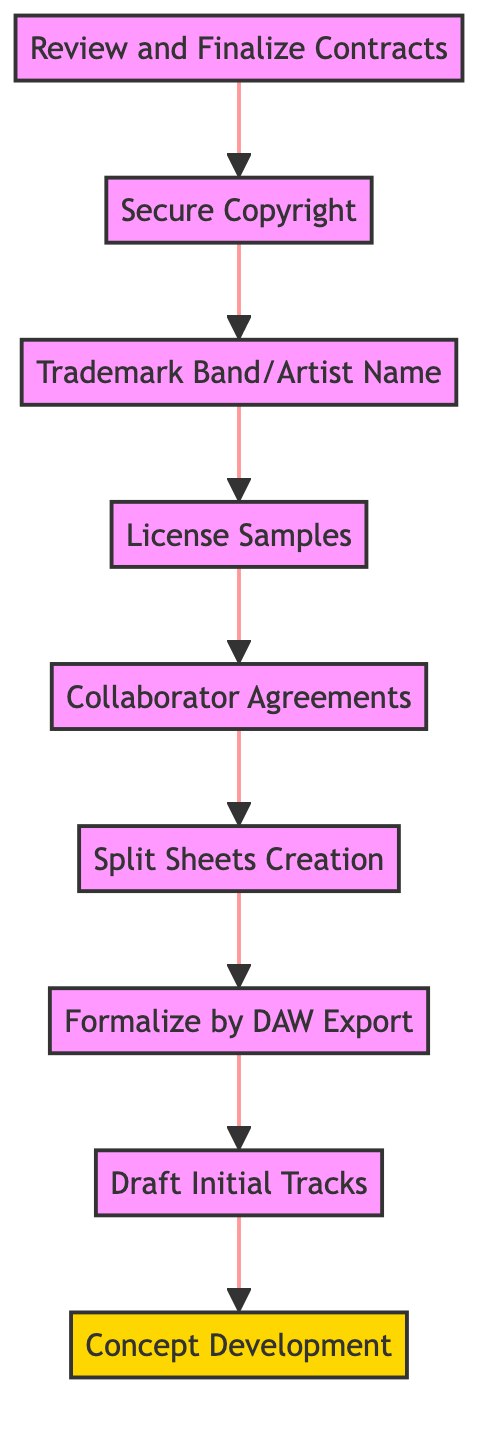What is the final stage in the diagram? The final stage in the flow chart is "Review and Finalize Contracts," which is located at the top of the diagram.
Answer: Review and Finalize Contracts How many total stages are present in the diagram? The diagram contains a total of nine stages, which can be counted by identifying each individual stage outlined in the flow.
Answer: Nine What stage comes immediately before the "Secure Copyright" stage? The stage that comes immediately before "Secure Copyright" is "Review and Finalize Contracts," as it directly leads to the next stage in the sequence.
Answer: Review and Finalize Contracts What is the purpose of "Collaborator Agreements"? The purpose of "Collaborator Agreements" is to "Draft agreements with collaborators, using a music industry attorney like those at Law Offices of Paul Fakler," as described in the diagram.
Answer: Draft agreements with collaborators What is the second stage in the flow chart? The second stage in the flow chart, following "Review and Finalize Contracts," is "Secure Copyright," as it follows directly in the outlined sequence.
Answer: Secure Copyright What stage focuses on initial compositions? The stage that focuses on initial compositions is "Draft Initial Tracks," as it specifically addresses the recording and production of the music.
Answer: Draft Initial Tracks Which stage addresses the protection of the band's name? The stage that addresses the protection of the band's name is "Trademark Band/Artist Name," as it involves the registration of the name with the USPTO.
Answer: Trademark Band/Artist Name What is the connection between "Split Sheets Creation" and "Collaborator Agreements"? "Split Sheets Creation" follows "Collaborator Agreements" in the flow, indicating that detailing ownership percentages among songwriters occurs after the agreements are drafted.
Answer: "Split Sheets Creation" follows "Collaborator Agreements" What is the starting point of the flow chart? The starting point of the flow chart is "Concept Development," which is the first stage leading to the subsequent actions outlined in the diagram.
Answer: Concept Development 